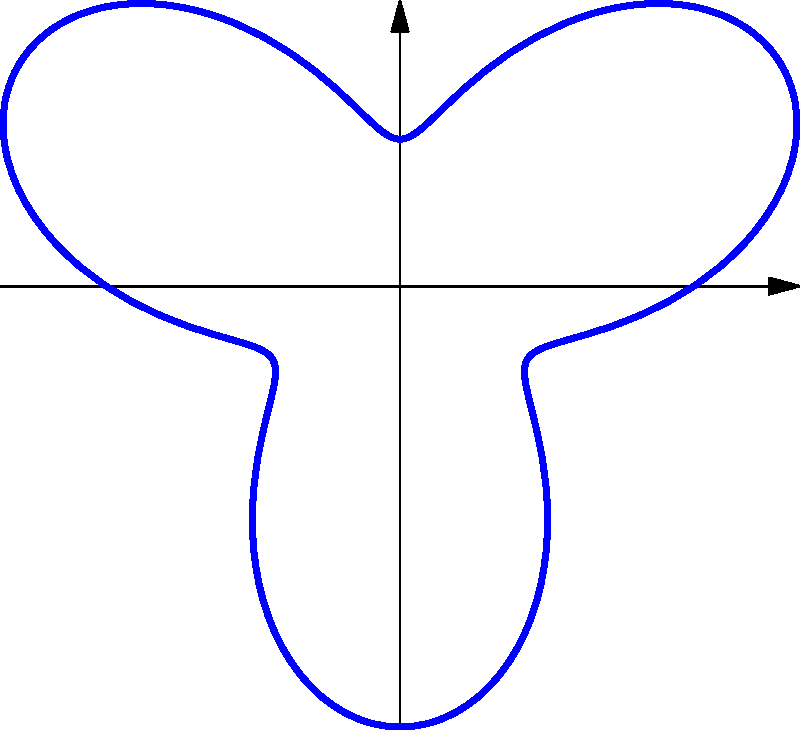In modern tattoo artistry, abstract wave-like designs are becoming increasingly popular. The polar equation $r = 2 + \sin(3\theta)$ can be used to create such a design. How many "petals" or loops does this curve have, and what is the significance of the number 3 in the equation for creating this tattoo design? To determine the number of petals or loops in this curve and understand the significance of the number 3, let's follow these steps:

1. The general form of the equation is $r = a + b\sin(n\theta)$ or $r = a + b\cos(n\theta)$, where $n$ determines the number of petals.

2. In our equation $r = 2 + \sin(3\theta)$, we can identify that $n = 3$.

3. For sine or cosine functions in polar equations, the number of petals is determined by:
   - If $n$ is odd, the number of petals equals $n$.
   - If $n$ is even, the number of petals equals $2n$.

4. In this case, $n = 3$, which is odd. Therefore, the curve has 3 petals or loops.

5. The significance of the number 3 in the equation:
   a) It directly determines the number of petals in the design.
   b) It controls the frequency of the sine function, creating 3 complete cycles as $\theta$ goes from 0 to $2\pi$.
   c) In tattoo design, this allows for the creation of a balanced, three-fold symmetry, which is often aesthetically pleasing and can hold symbolic meaning (e.g., representing past, present, and future).

6. The '2' in the equation shifts the entire curve outward from the origin, ensuring that the design doesn't intersect itself at the center, which is crucial for tattoo application.

This understanding allows tattoo artists to manipulate polar equations to create various abstract, symmetrical designs with different numbers of loops or petals, offering customization options for clients.
Answer: 3 petals; determines symmetry and loop count 